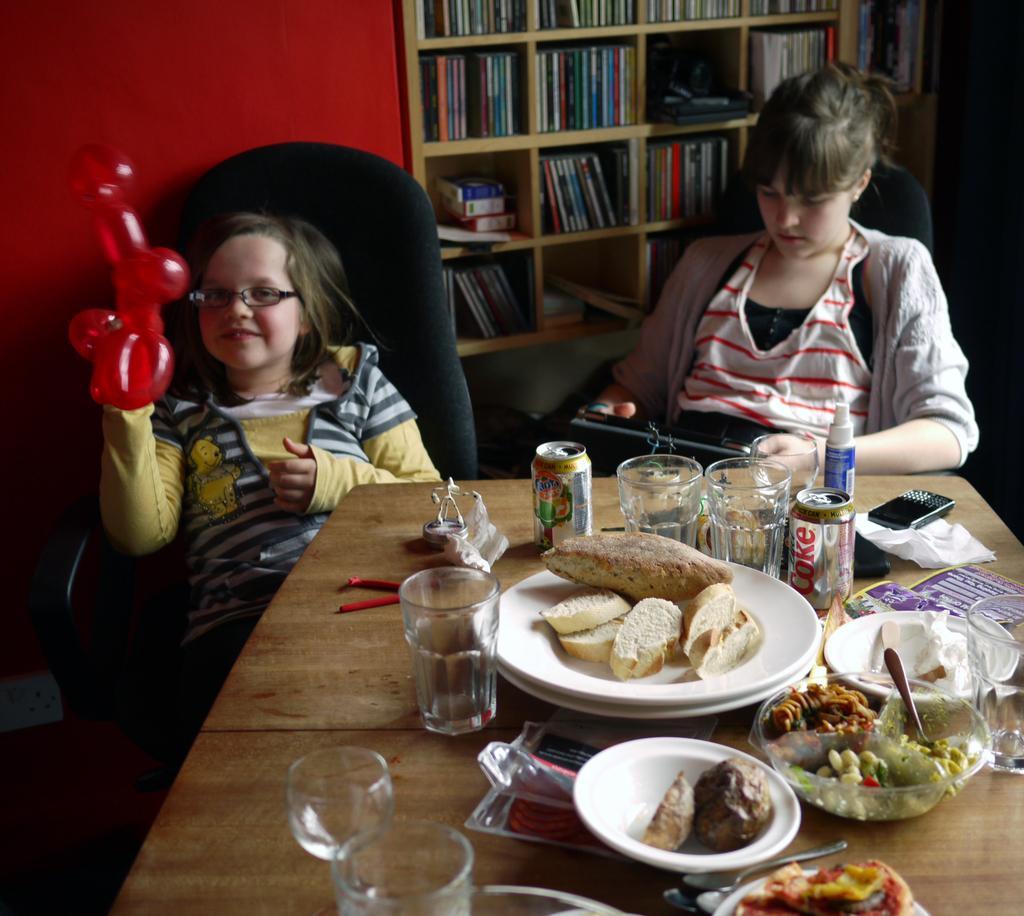Could you give a brief overview of what you see in this image? In this picture we can see two girls are sitting on chairs and one girl is holding a balloon, in front of them we can see a table, on this table we can see glasses, coke tins, plates, bowls, spoons, food items and some objects and in the background we can see a wall, shelves and books. 